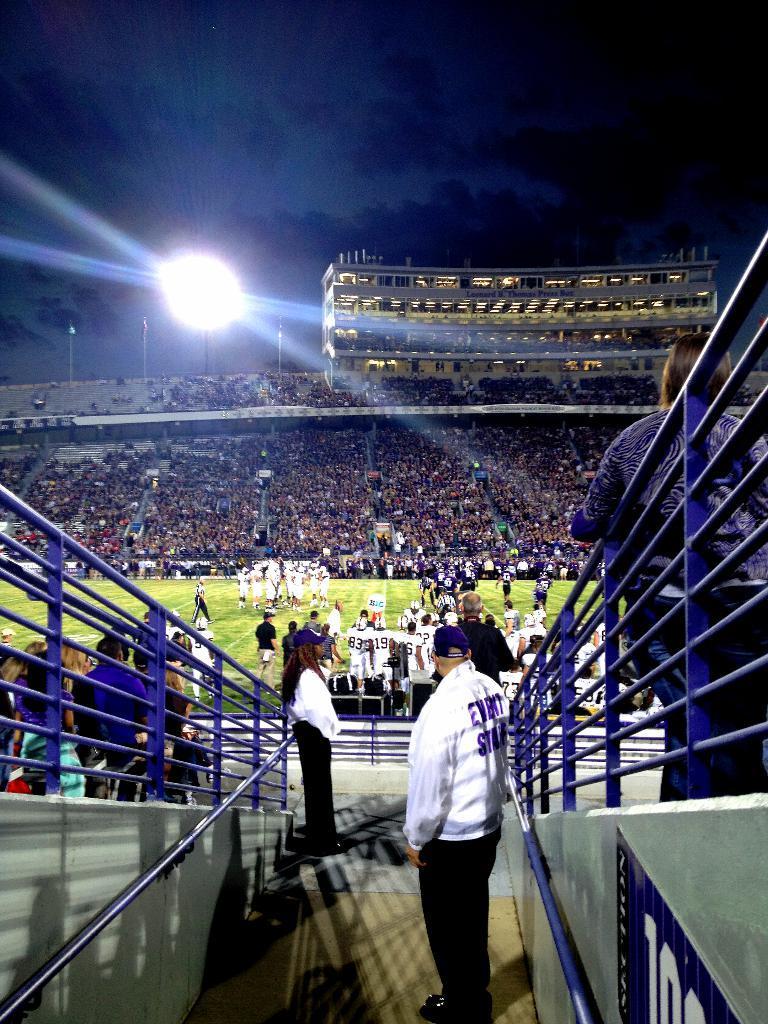Can you describe this image briefly? In the center of the image we can see a group of people are present in the stadium. At the top of the image we can see sky, light, pole are there. In the middle of the image ground is there. On the left and right side of the image stairs are present. At the bottom of the image floor is there. 